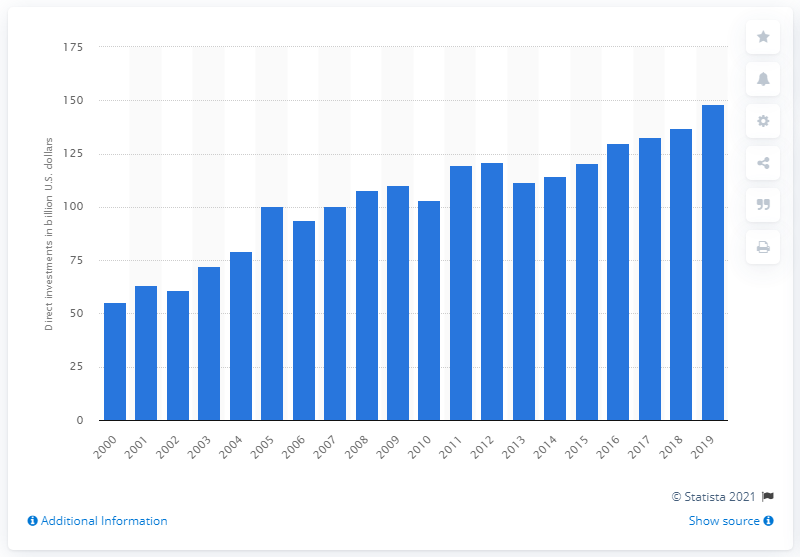Identify some key points in this picture. In 2019, a total of 148.26 dollars were invested in Germany. 